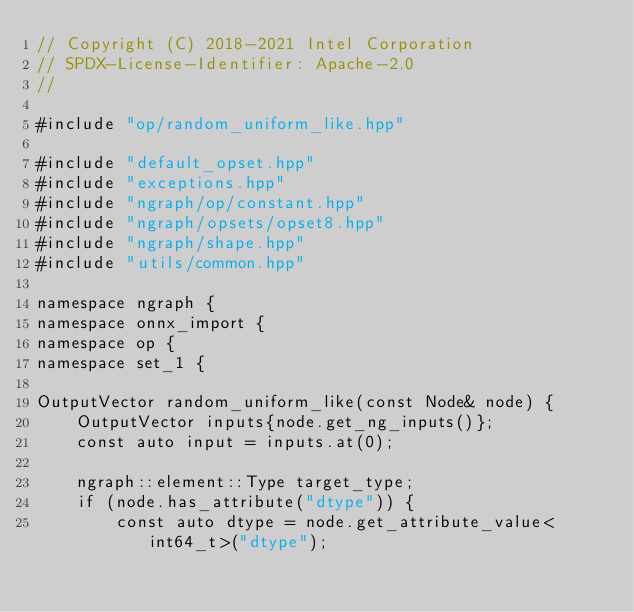Convert code to text. <code><loc_0><loc_0><loc_500><loc_500><_C++_>// Copyright (C) 2018-2021 Intel Corporation
// SPDX-License-Identifier: Apache-2.0
//

#include "op/random_uniform_like.hpp"

#include "default_opset.hpp"
#include "exceptions.hpp"
#include "ngraph/op/constant.hpp"
#include "ngraph/opsets/opset8.hpp"
#include "ngraph/shape.hpp"
#include "utils/common.hpp"

namespace ngraph {
namespace onnx_import {
namespace op {
namespace set_1 {

OutputVector random_uniform_like(const Node& node) {
    OutputVector inputs{node.get_ng_inputs()};
    const auto input = inputs.at(0);

    ngraph::element::Type target_type;
    if (node.has_attribute("dtype")) {
        const auto dtype = node.get_attribute_value<int64_t>("dtype");</code> 